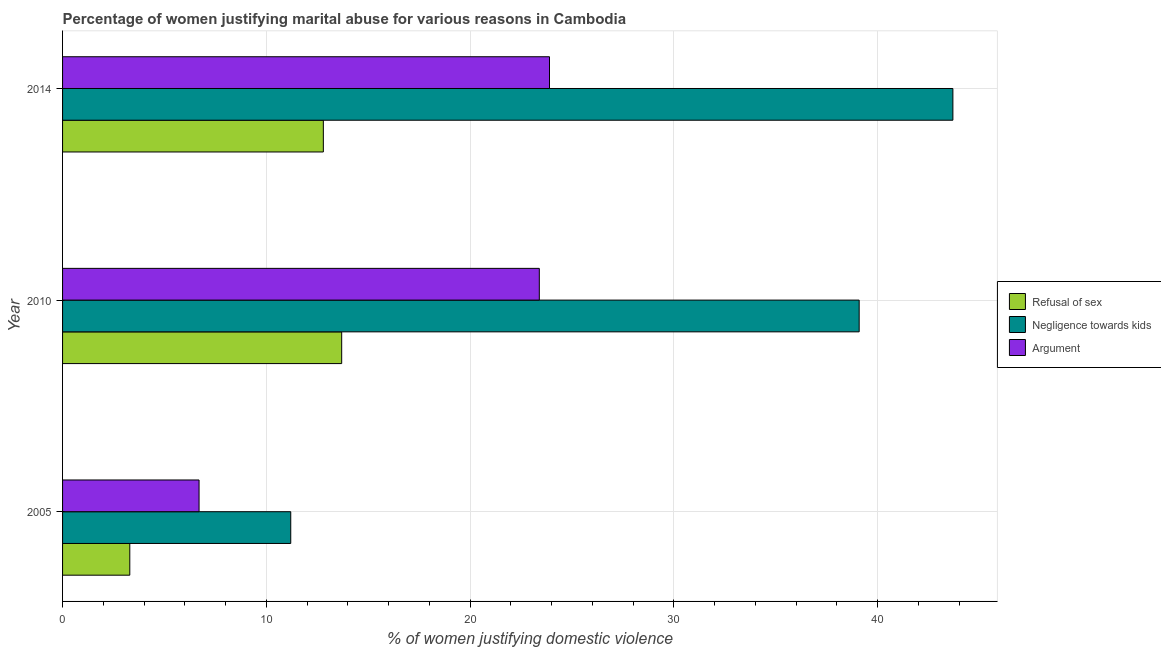How many different coloured bars are there?
Provide a short and direct response. 3. What is the label of the 1st group of bars from the top?
Your answer should be very brief. 2014. In how many cases, is the number of bars for a given year not equal to the number of legend labels?
Provide a short and direct response. 0. What is the percentage of women justifying domestic violence due to negligence towards kids in 2010?
Your answer should be very brief. 39.1. Across all years, what is the minimum percentage of women justifying domestic violence due to arguments?
Your response must be concise. 6.7. In which year was the percentage of women justifying domestic violence due to refusal of sex maximum?
Offer a very short reply. 2010. What is the total percentage of women justifying domestic violence due to refusal of sex in the graph?
Ensure brevity in your answer.  29.8. What is the difference between the percentage of women justifying domestic violence due to refusal of sex in 2005 and that in 2014?
Your answer should be compact. -9.5. What is the difference between the percentage of women justifying domestic violence due to arguments in 2005 and the percentage of women justifying domestic violence due to negligence towards kids in 2014?
Your answer should be compact. -37. What is the average percentage of women justifying domestic violence due to refusal of sex per year?
Provide a succinct answer. 9.93. In the year 2014, what is the difference between the percentage of women justifying domestic violence due to negligence towards kids and percentage of women justifying domestic violence due to arguments?
Your answer should be compact. 19.8. In how many years, is the percentage of women justifying domestic violence due to arguments greater than 22 %?
Provide a succinct answer. 2. What is the ratio of the percentage of women justifying domestic violence due to refusal of sex in 2005 to that in 2010?
Provide a succinct answer. 0.24. What is the difference between the highest and the second highest percentage of women justifying domestic violence due to negligence towards kids?
Offer a terse response. 4.6. In how many years, is the percentage of women justifying domestic violence due to negligence towards kids greater than the average percentage of women justifying domestic violence due to negligence towards kids taken over all years?
Offer a very short reply. 2. Is the sum of the percentage of women justifying domestic violence due to negligence towards kids in 2005 and 2014 greater than the maximum percentage of women justifying domestic violence due to arguments across all years?
Offer a very short reply. Yes. What does the 2nd bar from the top in 2010 represents?
Provide a succinct answer. Negligence towards kids. What does the 1st bar from the bottom in 2010 represents?
Your answer should be compact. Refusal of sex. How many bars are there?
Provide a succinct answer. 9. Are all the bars in the graph horizontal?
Your response must be concise. Yes. How many years are there in the graph?
Offer a terse response. 3. What is the difference between two consecutive major ticks on the X-axis?
Give a very brief answer. 10. Where does the legend appear in the graph?
Give a very brief answer. Center right. What is the title of the graph?
Provide a succinct answer. Percentage of women justifying marital abuse for various reasons in Cambodia. What is the label or title of the X-axis?
Offer a very short reply. % of women justifying domestic violence. What is the % of women justifying domestic violence in Negligence towards kids in 2005?
Provide a short and direct response. 11.2. What is the % of women justifying domestic violence of Argument in 2005?
Your answer should be compact. 6.7. What is the % of women justifying domestic violence in Refusal of sex in 2010?
Provide a short and direct response. 13.7. What is the % of women justifying domestic violence of Negligence towards kids in 2010?
Keep it short and to the point. 39.1. What is the % of women justifying domestic violence in Argument in 2010?
Offer a very short reply. 23.4. What is the % of women justifying domestic violence in Negligence towards kids in 2014?
Your response must be concise. 43.7. What is the % of women justifying domestic violence of Argument in 2014?
Provide a succinct answer. 23.9. Across all years, what is the maximum % of women justifying domestic violence of Refusal of sex?
Provide a succinct answer. 13.7. Across all years, what is the maximum % of women justifying domestic violence of Negligence towards kids?
Provide a succinct answer. 43.7. Across all years, what is the maximum % of women justifying domestic violence of Argument?
Keep it short and to the point. 23.9. Across all years, what is the minimum % of women justifying domestic violence in Argument?
Your response must be concise. 6.7. What is the total % of women justifying domestic violence in Refusal of sex in the graph?
Your answer should be compact. 29.8. What is the total % of women justifying domestic violence of Negligence towards kids in the graph?
Make the answer very short. 94. What is the difference between the % of women justifying domestic violence of Negligence towards kids in 2005 and that in 2010?
Your answer should be compact. -27.9. What is the difference between the % of women justifying domestic violence of Argument in 2005 and that in 2010?
Give a very brief answer. -16.7. What is the difference between the % of women justifying domestic violence in Negligence towards kids in 2005 and that in 2014?
Your response must be concise. -32.5. What is the difference between the % of women justifying domestic violence of Argument in 2005 and that in 2014?
Give a very brief answer. -17.2. What is the difference between the % of women justifying domestic violence of Argument in 2010 and that in 2014?
Offer a very short reply. -0.5. What is the difference between the % of women justifying domestic violence in Refusal of sex in 2005 and the % of women justifying domestic violence in Negligence towards kids in 2010?
Your answer should be compact. -35.8. What is the difference between the % of women justifying domestic violence of Refusal of sex in 2005 and the % of women justifying domestic violence of Argument in 2010?
Offer a terse response. -20.1. What is the difference between the % of women justifying domestic violence of Negligence towards kids in 2005 and the % of women justifying domestic violence of Argument in 2010?
Give a very brief answer. -12.2. What is the difference between the % of women justifying domestic violence of Refusal of sex in 2005 and the % of women justifying domestic violence of Negligence towards kids in 2014?
Offer a terse response. -40.4. What is the difference between the % of women justifying domestic violence in Refusal of sex in 2005 and the % of women justifying domestic violence in Argument in 2014?
Offer a very short reply. -20.6. What is the difference between the % of women justifying domestic violence of Negligence towards kids in 2005 and the % of women justifying domestic violence of Argument in 2014?
Your response must be concise. -12.7. What is the difference between the % of women justifying domestic violence in Refusal of sex in 2010 and the % of women justifying domestic violence in Negligence towards kids in 2014?
Your response must be concise. -30. What is the difference between the % of women justifying domestic violence in Refusal of sex in 2010 and the % of women justifying domestic violence in Argument in 2014?
Offer a terse response. -10.2. What is the difference between the % of women justifying domestic violence in Negligence towards kids in 2010 and the % of women justifying domestic violence in Argument in 2014?
Keep it short and to the point. 15.2. What is the average % of women justifying domestic violence in Refusal of sex per year?
Your response must be concise. 9.93. What is the average % of women justifying domestic violence in Negligence towards kids per year?
Your response must be concise. 31.33. In the year 2005, what is the difference between the % of women justifying domestic violence of Refusal of sex and % of women justifying domestic violence of Negligence towards kids?
Provide a short and direct response. -7.9. In the year 2010, what is the difference between the % of women justifying domestic violence in Refusal of sex and % of women justifying domestic violence in Negligence towards kids?
Provide a succinct answer. -25.4. In the year 2010, what is the difference between the % of women justifying domestic violence in Refusal of sex and % of women justifying domestic violence in Argument?
Your answer should be very brief. -9.7. In the year 2014, what is the difference between the % of women justifying domestic violence in Refusal of sex and % of women justifying domestic violence in Negligence towards kids?
Offer a terse response. -30.9. In the year 2014, what is the difference between the % of women justifying domestic violence in Refusal of sex and % of women justifying domestic violence in Argument?
Offer a terse response. -11.1. In the year 2014, what is the difference between the % of women justifying domestic violence of Negligence towards kids and % of women justifying domestic violence of Argument?
Provide a succinct answer. 19.8. What is the ratio of the % of women justifying domestic violence of Refusal of sex in 2005 to that in 2010?
Your response must be concise. 0.24. What is the ratio of the % of women justifying domestic violence of Negligence towards kids in 2005 to that in 2010?
Your response must be concise. 0.29. What is the ratio of the % of women justifying domestic violence in Argument in 2005 to that in 2010?
Keep it short and to the point. 0.29. What is the ratio of the % of women justifying domestic violence in Refusal of sex in 2005 to that in 2014?
Offer a very short reply. 0.26. What is the ratio of the % of women justifying domestic violence in Negligence towards kids in 2005 to that in 2014?
Your answer should be compact. 0.26. What is the ratio of the % of women justifying domestic violence in Argument in 2005 to that in 2014?
Provide a succinct answer. 0.28. What is the ratio of the % of women justifying domestic violence of Refusal of sex in 2010 to that in 2014?
Your answer should be very brief. 1.07. What is the ratio of the % of women justifying domestic violence in Negligence towards kids in 2010 to that in 2014?
Provide a short and direct response. 0.89. What is the ratio of the % of women justifying domestic violence in Argument in 2010 to that in 2014?
Your answer should be very brief. 0.98. What is the difference between the highest and the lowest % of women justifying domestic violence in Negligence towards kids?
Give a very brief answer. 32.5. What is the difference between the highest and the lowest % of women justifying domestic violence in Argument?
Offer a terse response. 17.2. 